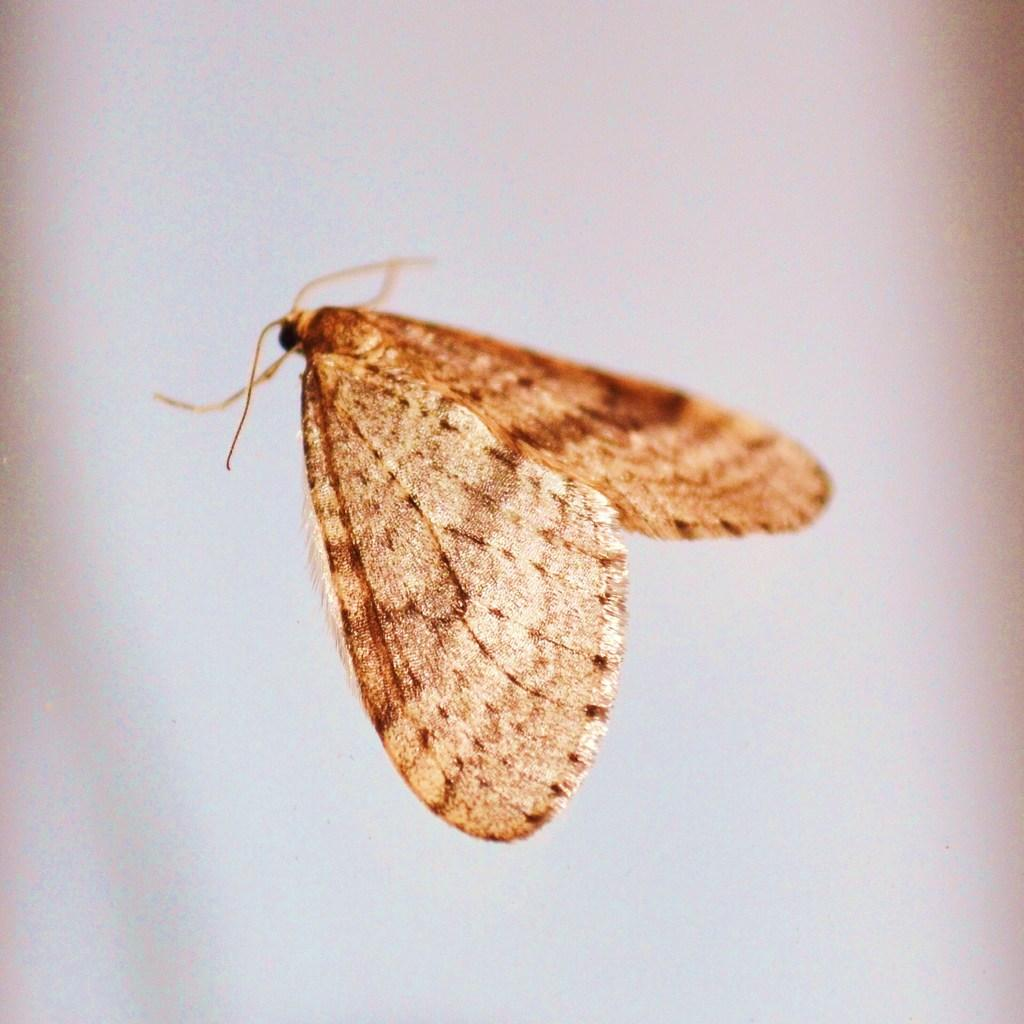What is the main subject of the image? There is a butterfly in the center of the image. What is the background of the image? The background of the image is white. What type of exchange is taking place in the image? There is no exchange taking place in the image; it features a butterfly in the center of a white background. What is the butterfly's attention focused on in the image? The butterfly's attention cannot be determined from the image, as it is a still image and does not show the butterfly's focus. 